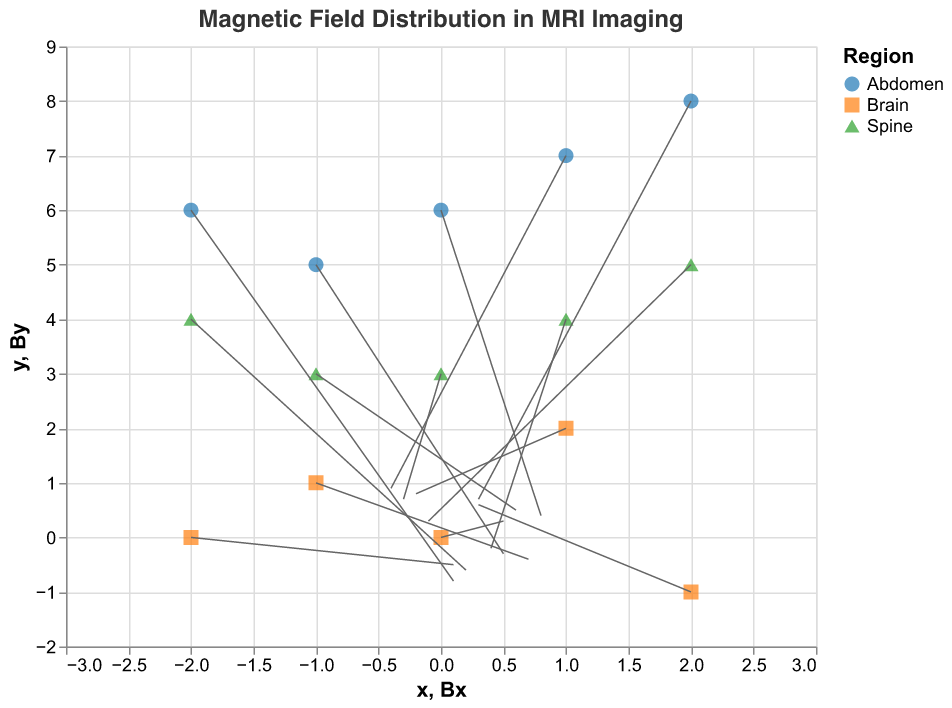What is the title of the plot? The title of the plot is located at the top of the figure and provides an overview of what the plot is about.
Answer: Magnetic Field Distribution in MRI Imaging How many different body regions are represented in the plot? By looking at the legend, you can identify the unique entries that correspond to the different body regions.
Answer: 3 Which body region shows the data point with the highest x-value? By checking the data points on the x-axis and identifying the corresponding body regions via colors or shapes, we can find the region. The highest x-value is 2.
Answer: Brain What is the direction of the magnetic field (Bx, By) at point (0,3)? Locate the point where x=0 and y=3, then look at the direction of the arrow originating from this point: (Bx, By) values are shown and indicating the direction.
Answer: (-0.3, 0.7) What is the range of y-values shown in the plot? The range is determined by checking the minimum and maximum values represented on the y-axis. The minimum y value is -2, and the maximum y value is 9.
Answer: -2 to 9 Is there any data point at y=0? If so, which region does it belong to? Identify points where y=0 on the plot. There is one such point, which we can confirm by looking at its color or shape to determine the region.
Answer: Brain What is the average Bx value for points in the Spine region? Locate all points in the Spine region, sum their Bx values and divide by the count of points. \( Bx_{\text{Spine}} = (-0.3 + 0.4 + 0.6 - 0.1 + 0.2)/5 = 0.16 \)
Answer: 0.16 Compare the magnetic field strengths (Bx, By) at (1,2) for the Brain with (1,4) for the Spine. Which one is stronger? Compute the Euclidean norm of (Bx, By) for both points and compare. Brain: \(\sqrt{(-0.2)^2 + 0.8^2} = \sqrt{0.04 + 0.64} = \sqrt{0.68} ≈ 0.82\), Spine: \(\sqrt{0.4^2 + (-0.2)^2} = \sqrt{0.16 + 0.04} = \sqrt{0.2} ≈ 0.45\). Hence, Brain has a stronger magnetic field at these points.
Answer: Brain Identify the point with maximum By value and specify its coordinates and region. Review all (By) components and identify the maximum value, then note its coordinates and region. Max By is 0.9 at (1,7) in the Abdomen.
Answer: (1,7), Abdomen 